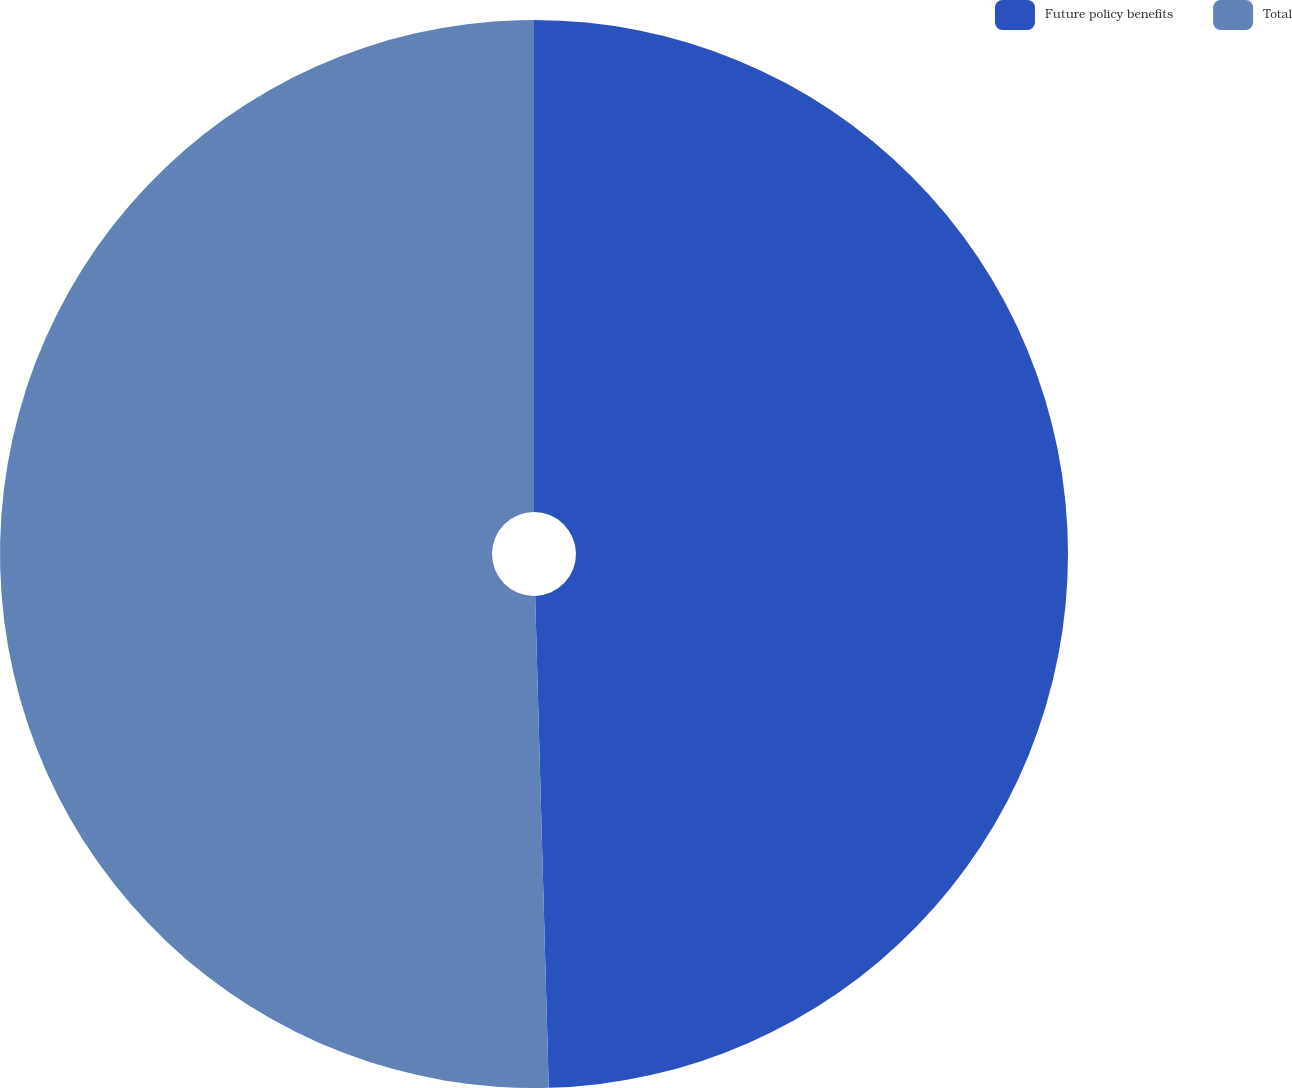Convert chart to OTSL. <chart><loc_0><loc_0><loc_500><loc_500><pie_chart><fcel>Future policy benefits<fcel>Total<nl><fcel>49.56%<fcel>50.44%<nl></chart> 